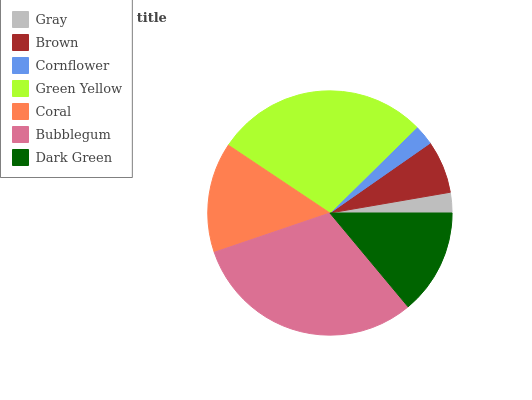Is Cornflower the minimum?
Answer yes or no. Yes. Is Bubblegum the maximum?
Answer yes or no. Yes. Is Brown the minimum?
Answer yes or no. No. Is Brown the maximum?
Answer yes or no. No. Is Brown greater than Gray?
Answer yes or no. Yes. Is Gray less than Brown?
Answer yes or no. Yes. Is Gray greater than Brown?
Answer yes or no. No. Is Brown less than Gray?
Answer yes or no. No. Is Dark Green the high median?
Answer yes or no. Yes. Is Dark Green the low median?
Answer yes or no. Yes. Is Green Yellow the high median?
Answer yes or no. No. Is Green Yellow the low median?
Answer yes or no. No. 